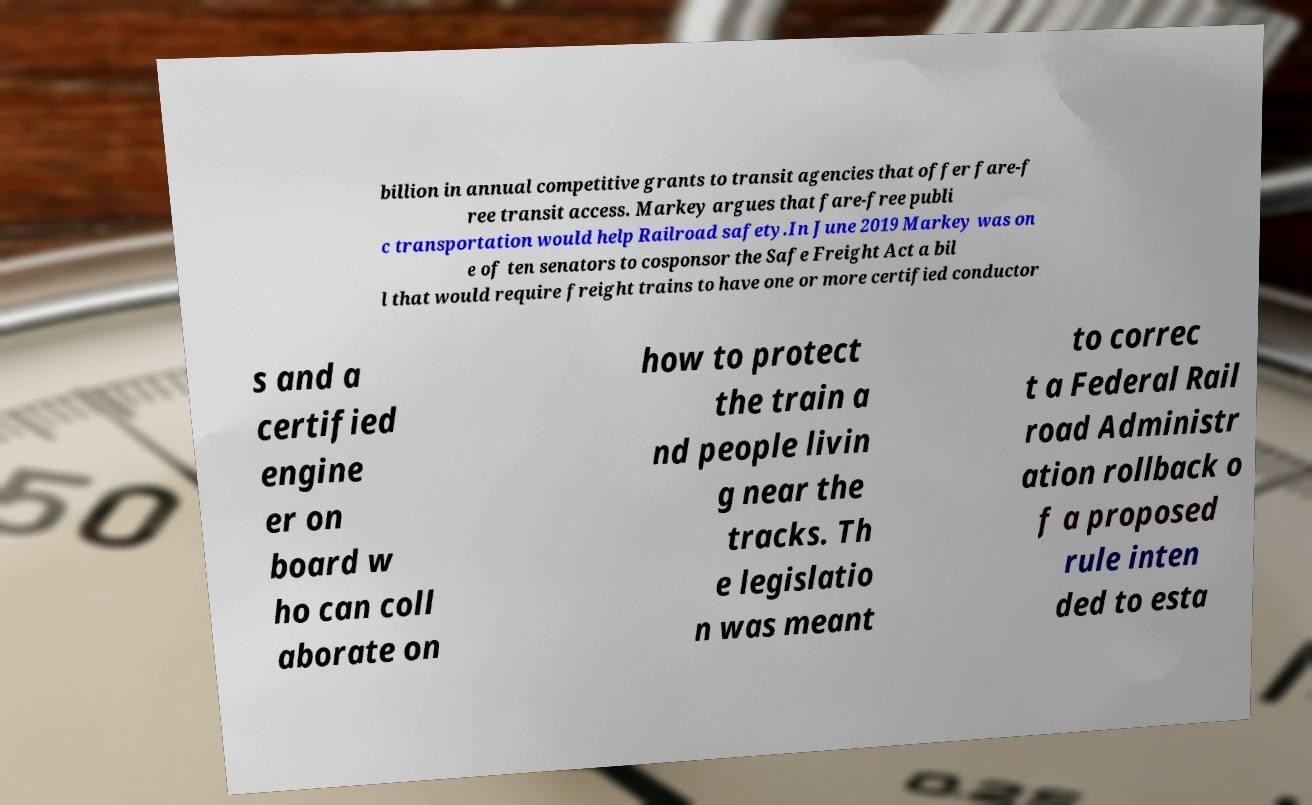There's text embedded in this image that I need extracted. Can you transcribe it verbatim? billion in annual competitive grants to transit agencies that offer fare-f ree transit access. Markey argues that fare-free publi c transportation would help Railroad safety.In June 2019 Markey was on e of ten senators to cosponsor the Safe Freight Act a bil l that would require freight trains to have one or more certified conductor s and a certified engine er on board w ho can coll aborate on how to protect the train a nd people livin g near the tracks. Th e legislatio n was meant to correc t a Federal Rail road Administr ation rollback o f a proposed rule inten ded to esta 